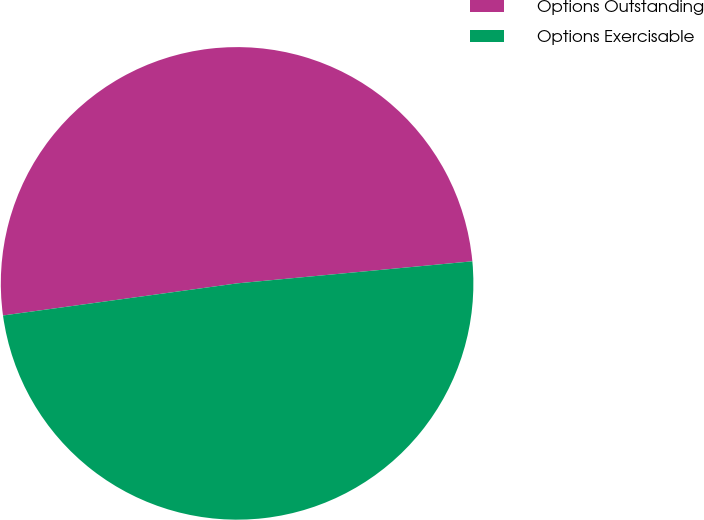Convert chart to OTSL. <chart><loc_0><loc_0><loc_500><loc_500><pie_chart><fcel>Options Outstanding<fcel>Options Exercisable<nl><fcel>50.68%<fcel>49.32%<nl></chart> 